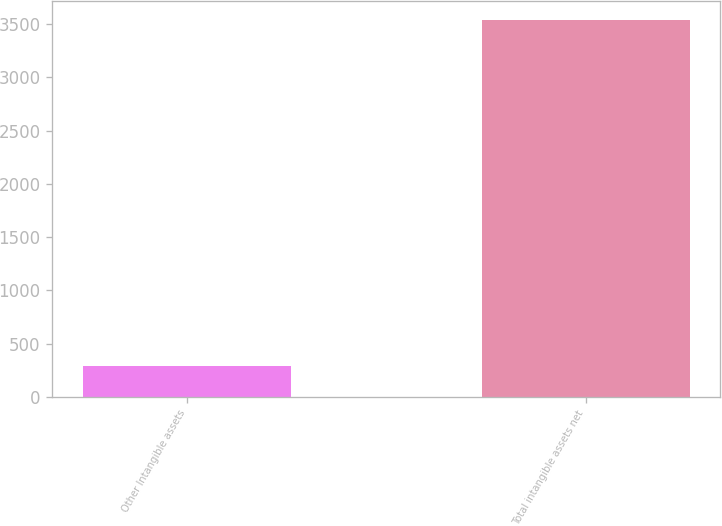<chart> <loc_0><loc_0><loc_500><loc_500><bar_chart><fcel>Other Intangible assets<fcel>Total intangible assets net<nl><fcel>291<fcel>3541<nl></chart> 